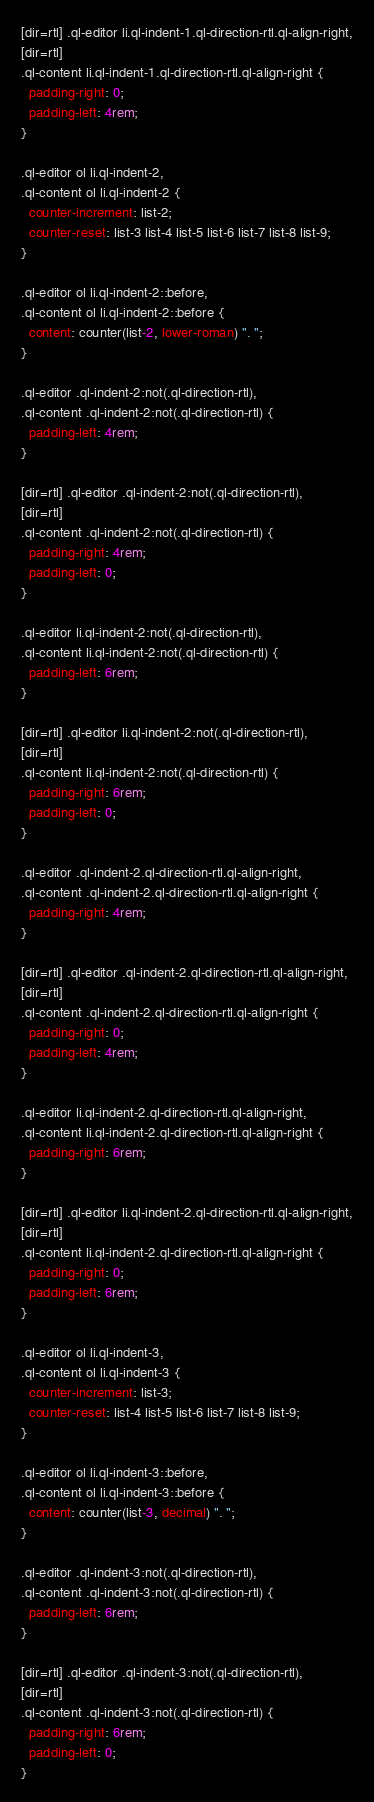Convert code to text. <code><loc_0><loc_0><loc_500><loc_500><_CSS_>[dir=rtl] .ql-editor li.ql-indent-1.ql-direction-rtl.ql-align-right,
[dir=rtl]
.ql-content li.ql-indent-1.ql-direction-rtl.ql-align-right {
  padding-right: 0;
  padding-left: 4rem;
}

.ql-editor ol li.ql-indent-2,
.ql-content ol li.ql-indent-2 {
  counter-increment: list-2;
  counter-reset: list-3 list-4 list-5 list-6 list-7 list-8 list-9;
}

.ql-editor ol li.ql-indent-2::before,
.ql-content ol li.ql-indent-2::before {
  content: counter(list-2, lower-roman) ". ";
}

.ql-editor .ql-indent-2:not(.ql-direction-rtl),
.ql-content .ql-indent-2:not(.ql-direction-rtl) {
  padding-left: 4rem;
}

[dir=rtl] .ql-editor .ql-indent-2:not(.ql-direction-rtl),
[dir=rtl]
.ql-content .ql-indent-2:not(.ql-direction-rtl) {
  padding-right: 4rem;
  padding-left: 0;
}

.ql-editor li.ql-indent-2:not(.ql-direction-rtl),
.ql-content li.ql-indent-2:not(.ql-direction-rtl) {
  padding-left: 6rem;
}

[dir=rtl] .ql-editor li.ql-indent-2:not(.ql-direction-rtl),
[dir=rtl]
.ql-content li.ql-indent-2:not(.ql-direction-rtl) {
  padding-right: 6rem;
  padding-left: 0;
}

.ql-editor .ql-indent-2.ql-direction-rtl.ql-align-right,
.ql-content .ql-indent-2.ql-direction-rtl.ql-align-right {
  padding-right: 4rem;
}

[dir=rtl] .ql-editor .ql-indent-2.ql-direction-rtl.ql-align-right,
[dir=rtl]
.ql-content .ql-indent-2.ql-direction-rtl.ql-align-right {
  padding-right: 0;
  padding-left: 4rem;
}

.ql-editor li.ql-indent-2.ql-direction-rtl.ql-align-right,
.ql-content li.ql-indent-2.ql-direction-rtl.ql-align-right {
  padding-right: 6rem;
}

[dir=rtl] .ql-editor li.ql-indent-2.ql-direction-rtl.ql-align-right,
[dir=rtl]
.ql-content li.ql-indent-2.ql-direction-rtl.ql-align-right {
  padding-right: 0;
  padding-left: 6rem;
}

.ql-editor ol li.ql-indent-3,
.ql-content ol li.ql-indent-3 {
  counter-increment: list-3;
  counter-reset: list-4 list-5 list-6 list-7 list-8 list-9;
}

.ql-editor ol li.ql-indent-3::before,
.ql-content ol li.ql-indent-3::before {
  content: counter(list-3, decimal) ". ";
}

.ql-editor .ql-indent-3:not(.ql-direction-rtl),
.ql-content .ql-indent-3:not(.ql-direction-rtl) {
  padding-left: 6rem;
}

[dir=rtl] .ql-editor .ql-indent-3:not(.ql-direction-rtl),
[dir=rtl]
.ql-content .ql-indent-3:not(.ql-direction-rtl) {
  padding-right: 6rem;
  padding-left: 0;
}
</code> 